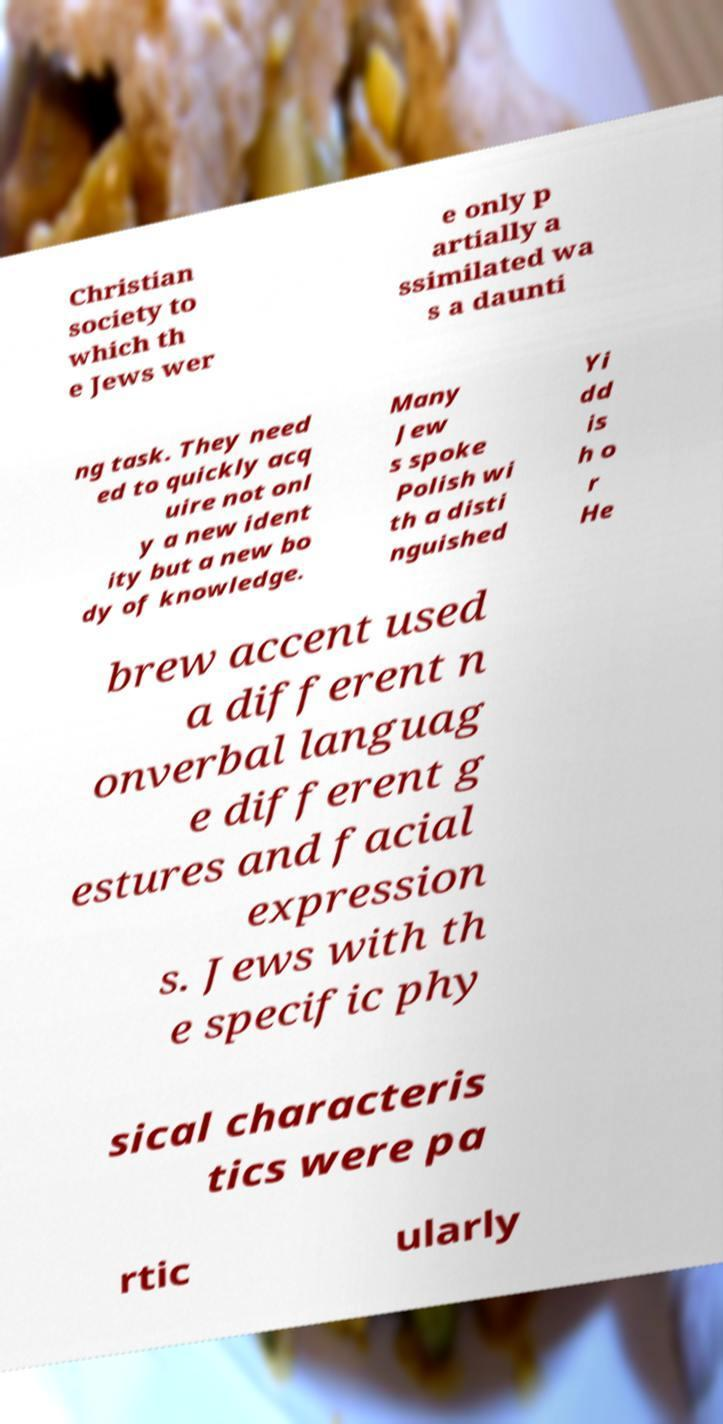Could you assist in decoding the text presented in this image and type it out clearly? Christian society to which th e Jews wer e only p artially a ssimilated wa s a daunti ng task. They need ed to quickly acq uire not onl y a new ident ity but a new bo dy of knowledge. Many Jew s spoke Polish wi th a disti nguished Yi dd is h o r He brew accent used a different n onverbal languag e different g estures and facial expression s. Jews with th e specific phy sical characteris tics were pa rtic ularly 